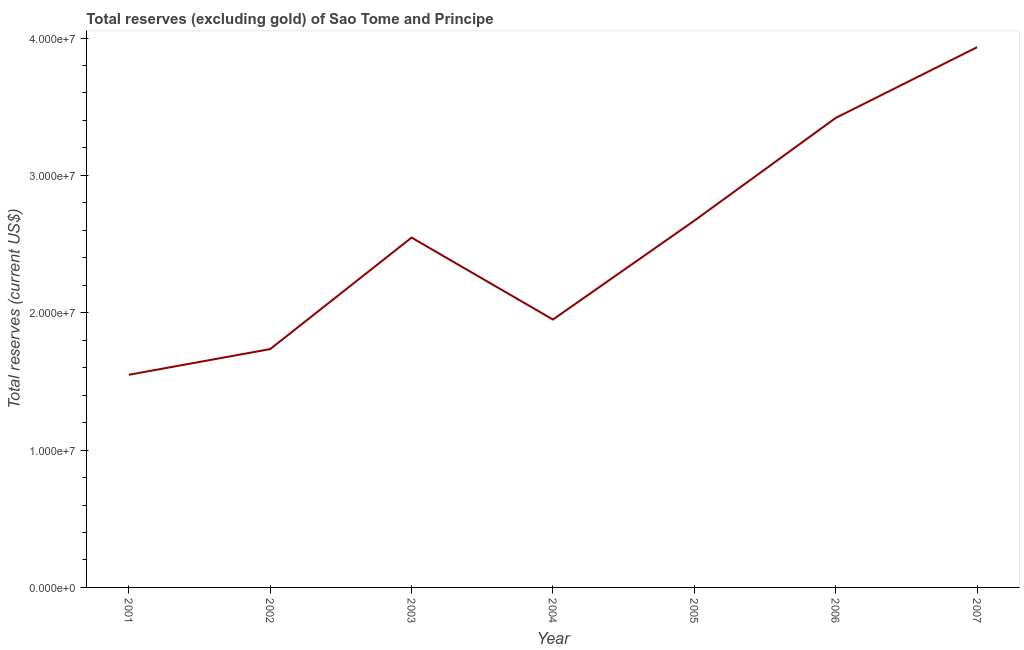What is the total reserves (excluding gold) in 2007?
Your answer should be very brief. 3.93e+07. Across all years, what is the maximum total reserves (excluding gold)?
Offer a very short reply. 3.93e+07. Across all years, what is the minimum total reserves (excluding gold)?
Offer a very short reply. 1.55e+07. What is the sum of the total reserves (excluding gold)?
Ensure brevity in your answer.  1.78e+08. What is the difference between the total reserves (excluding gold) in 2001 and 2003?
Provide a short and direct response. -9.99e+06. What is the average total reserves (excluding gold) per year?
Give a very brief answer. 2.54e+07. What is the median total reserves (excluding gold)?
Provide a succinct answer. 2.55e+07. What is the ratio of the total reserves (excluding gold) in 2005 to that in 2006?
Offer a very short reply. 0.78. Is the total reserves (excluding gold) in 2003 less than that in 2007?
Your response must be concise. Yes. What is the difference between the highest and the second highest total reserves (excluding gold)?
Ensure brevity in your answer.  5.15e+06. What is the difference between the highest and the lowest total reserves (excluding gold)?
Provide a short and direct response. 2.38e+07. In how many years, is the total reserves (excluding gold) greater than the average total reserves (excluding gold) taken over all years?
Make the answer very short. 4. How many lines are there?
Provide a succinct answer. 1. Are the values on the major ticks of Y-axis written in scientific E-notation?
Offer a very short reply. Yes. Does the graph contain any zero values?
Give a very brief answer. No. Does the graph contain grids?
Make the answer very short. No. What is the title of the graph?
Provide a succinct answer. Total reserves (excluding gold) of Sao Tome and Principe. What is the label or title of the X-axis?
Provide a succinct answer. Year. What is the label or title of the Y-axis?
Give a very brief answer. Total reserves (current US$). What is the Total reserves (current US$) of 2001?
Your answer should be very brief. 1.55e+07. What is the Total reserves (current US$) in 2002?
Ensure brevity in your answer.  1.74e+07. What is the Total reserves (current US$) in 2003?
Make the answer very short. 2.55e+07. What is the Total reserves (current US$) of 2004?
Keep it short and to the point. 1.95e+07. What is the Total reserves (current US$) of 2005?
Your response must be concise. 2.67e+07. What is the Total reserves (current US$) in 2006?
Ensure brevity in your answer.  3.42e+07. What is the Total reserves (current US$) of 2007?
Your answer should be very brief. 3.93e+07. What is the difference between the Total reserves (current US$) in 2001 and 2002?
Ensure brevity in your answer.  -1.87e+06. What is the difference between the Total reserves (current US$) in 2001 and 2003?
Offer a terse response. -9.99e+06. What is the difference between the Total reserves (current US$) in 2001 and 2004?
Ensure brevity in your answer.  -4.02e+06. What is the difference between the Total reserves (current US$) in 2001 and 2005?
Give a very brief answer. -1.12e+07. What is the difference between the Total reserves (current US$) in 2001 and 2006?
Provide a short and direct response. -1.87e+07. What is the difference between the Total reserves (current US$) in 2001 and 2007?
Offer a very short reply. -2.38e+07. What is the difference between the Total reserves (current US$) in 2002 and 2003?
Ensure brevity in your answer.  -8.12e+06. What is the difference between the Total reserves (current US$) in 2002 and 2004?
Make the answer very short. -2.15e+06. What is the difference between the Total reserves (current US$) in 2002 and 2005?
Make the answer very short. -9.35e+06. What is the difference between the Total reserves (current US$) in 2002 and 2006?
Provide a short and direct response. -1.68e+07. What is the difference between the Total reserves (current US$) in 2002 and 2007?
Offer a terse response. -2.20e+07. What is the difference between the Total reserves (current US$) in 2003 and 2004?
Make the answer very short. 5.97e+06. What is the difference between the Total reserves (current US$) in 2003 and 2005?
Your answer should be compact. -1.23e+06. What is the difference between the Total reserves (current US$) in 2003 and 2006?
Give a very brief answer. -8.71e+06. What is the difference between the Total reserves (current US$) in 2003 and 2007?
Ensure brevity in your answer.  -1.39e+07. What is the difference between the Total reserves (current US$) in 2004 and 2005?
Offer a very short reply. -7.20e+06. What is the difference between the Total reserves (current US$) in 2004 and 2006?
Make the answer very short. -1.47e+07. What is the difference between the Total reserves (current US$) in 2004 and 2007?
Your response must be concise. -1.98e+07. What is the difference between the Total reserves (current US$) in 2005 and 2006?
Offer a very short reply. -7.48e+06. What is the difference between the Total reserves (current US$) in 2005 and 2007?
Your response must be concise. -1.26e+07. What is the difference between the Total reserves (current US$) in 2006 and 2007?
Your answer should be compact. -5.15e+06. What is the ratio of the Total reserves (current US$) in 2001 to that in 2002?
Your response must be concise. 0.89. What is the ratio of the Total reserves (current US$) in 2001 to that in 2003?
Offer a terse response. 0.61. What is the ratio of the Total reserves (current US$) in 2001 to that in 2004?
Offer a very short reply. 0.79. What is the ratio of the Total reserves (current US$) in 2001 to that in 2005?
Offer a very short reply. 0.58. What is the ratio of the Total reserves (current US$) in 2001 to that in 2006?
Provide a short and direct response. 0.45. What is the ratio of the Total reserves (current US$) in 2001 to that in 2007?
Ensure brevity in your answer.  0.39. What is the ratio of the Total reserves (current US$) in 2002 to that in 2003?
Ensure brevity in your answer.  0.68. What is the ratio of the Total reserves (current US$) in 2002 to that in 2004?
Your answer should be very brief. 0.89. What is the ratio of the Total reserves (current US$) in 2002 to that in 2005?
Your response must be concise. 0.65. What is the ratio of the Total reserves (current US$) in 2002 to that in 2006?
Your answer should be compact. 0.51. What is the ratio of the Total reserves (current US$) in 2002 to that in 2007?
Provide a succinct answer. 0.44. What is the ratio of the Total reserves (current US$) in 2003 to that in 2004?
Your response must be concise. 1.31. What is the ratio of the Total reserves (current US$) in 2003 to that in 2005?
Your response must be concise. 0.95. What is the ratio of the Total reserves (current US$) in 2003 to that in 2006?
Give a very brief answer. 0.74. What is the ratio of the Total reserves (current US$) in 2003 to that in 2007?
Make the answer very short. 0.65. What is the ratio of the Total reserves (current US$) in 2004 to that in 2005?
Your response must be concise. 0.73. What is the ratio of the Total reserves (current US$) in 2004 to that in 2006?
Your response must be concise. 0.57. What is the ratio of the Total reserves (current US$) in 2004 to that in 2007?
Provide a short and direct response. 0.5. What is the ratio of the Total reserves (current US$) in 2005 to that in 2006?
Give a very brief answer. 0.78. What is the ratio of the Total reserves (current US$) in 2005 to that in 2007?
Your response must be concise. 0.68. What is the ratio of the Total reserves (current US$) in 2006 to that in 2007?
Give a very brief answer. 0.87. 